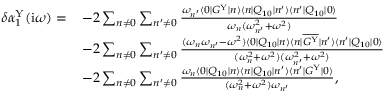Convert formula to latex. <formula><loc_0><loc_0><loc_500><loc_500>\begin{array} { r l } { \delta \alpha _ { 1 } ^ { Y } ( i \omega ) = \, } & { - 2 \sum _ { n \ne 0 } \sum _ { n ^ { \prime } \ne 0 } \frac { \omega _ { n ^ { \prime } } \langle 0 | G ^ { Y } | n \rangle \langle n | Q _ { 1 0 } | n ^ { \prime } \rangle \langle n ^ { \prime } | Q _ { 1 0 } | 0 \rangle } { \omega _ { n } ( \omega _ { n ^ { \prime } } ^ { 2 } + \omega ^ { 2 } ) } } \\ & { - 2 \sum _ { n \ne 0 } \sum _ { n ^ { \prime } \ne 0 } \frac { ( \omega _ { n } \omega _ { n ^ { \prime } } - \omega ^ { 2 } ) \langle 0 | Q _ { 1 0 } | n \rangle \langle n | \overline { { G ^ { Y } } } | n ^ { \prime } \rangle \langle n ^ { \prime } | Q _ { 1 0 } | 0 \rangle } { ( \omega _ { n } ^ { 2 } + \omega ^ { 2 } ) ( \omega _ { n ^ { \prime } } ^ { 2 } + \omega ^ { 2 } ) } } \\ & { - 2 \sum _ { n \ne 0 } \sum _ { n ^ { \prime } \ne 0 } \frac { \omega _ { n } \langle 0 | Q _ { 1 0 } | n \rangle \langle n | Q _ { 1 0 } | n ^ { \prime } \rangle \langle n ^ { \prime } | G ^ { Y } | 0 \rangle } { ( \omega _ { n } ^ { 2 } + \omega ^ { 2 } ) \omega _ { n ^ { \prime } } } , } \end{array}</formula> 